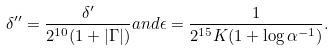Convert formula to latex. <formula><loc_0><loc_0><loc_500><loc_500>\delta ^ { \prime \prime } = \frac { \delta ^ { \prime } } { 2 ^ { 1 0 } ( 1 + | \Gamma | ) } a n d \epsilon = \frac { 1 } { 2 ^ { 1 5 } K ( 1 + \log \alpha ^ { - 1 } ) } .</formula> 